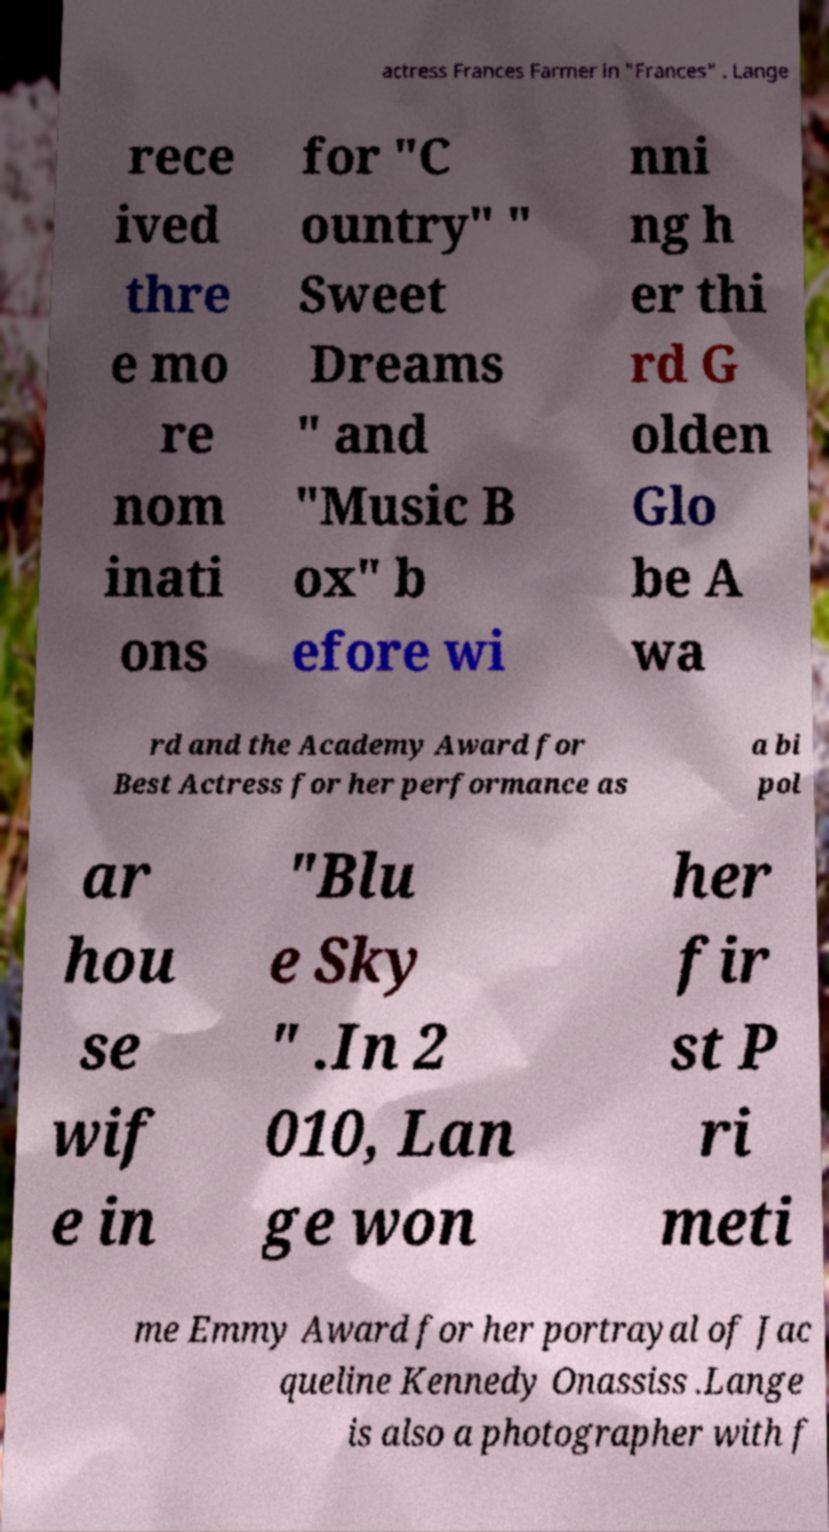What messages or text are displayed in this image? I need them in a readable, typed format. actress Frances Farmer in "Frances" . Lange rece ived thre e mo re nom inati ons for "C ountry" " Sweet Dreams " and "Music B ox" b efore wi nni ng h er thi rd G olden Glo be A wa rd and the Academy Award for Best Actress for her performance as a bi pol ar hou se wif e in "Blu e Sky " .In 2 010, Lan ge won her fir st P ri meti me Emmy Award for her portrayal of Jac queline Kennedy Onassiss .Lange is also a photographer with f 